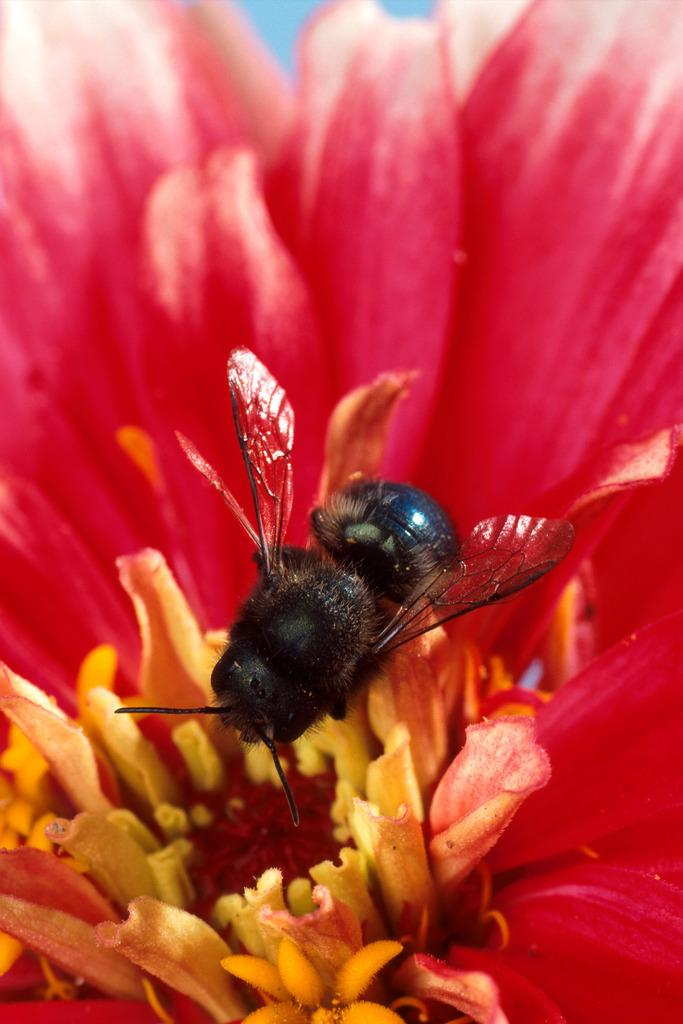What type of insect is in the image? There is a honey bee in the image. Where is the honey bee located in the image? The honey bee is on a flower. What type of knowledge is the honey bee seeking on the flower in the image? The image does not provide any information about the honey bee's intentions or knowledge-seeking activities. 